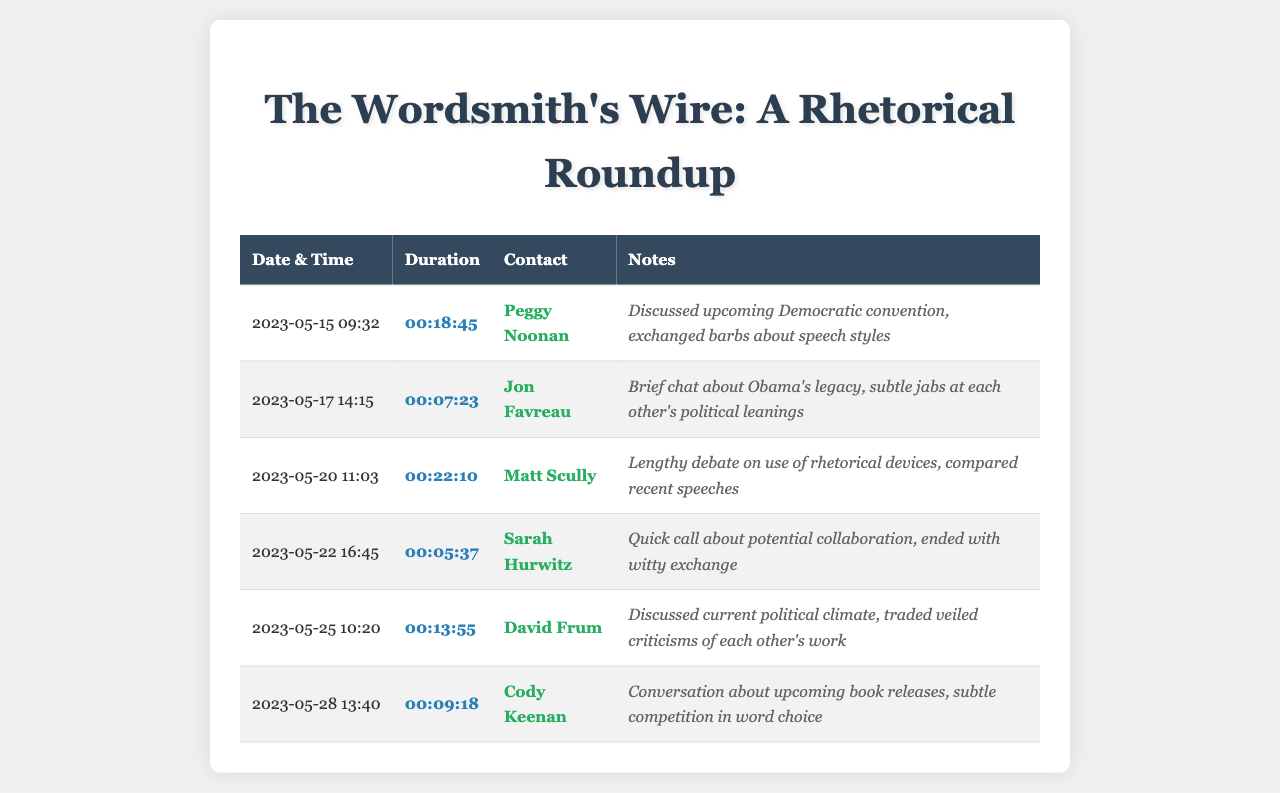what is the date of the longest call? The longest call is on May 20, 2023, with a duration of 22 minutes and 10 seconds.
Answer: May 20, 2023 who was the contact for the briefest call? The briefest call lasted 5 minutes and 37 seconds with Sarah Hurwitz.
Answer: Sarah Hurwitz how many calls were made in total? There are six calls listed in the document, each with a specific date and time.
Answer: 6 which speechwriter had a conversation about Obama's legacy? The conversation about Obama's legacy was with Jon Favreau.
Answer: Jon Favreau what was the duration of the call with Peggy Noonan? The call with Peggy Noonan lasted 18 minutes and 45 seconds.
Answer: 00:18:45 which call included a discussion about potential collaboration? The call discussing potential collaboration was with Sarah Hurwitz.
Answer: Sarah Hurwitz what is the average duration of the calls? To find the average, you can add up all the durations and divide by the number of calls, resulting in approximately 12 minutes and 7 seconds per call.
Answer: 12:07 what was the common theme in the conversations? The common themes included discussions of political contexts, rhetorical devices, and subtle competition among speechwriters.
Answer: Political contexts and competition when did the last call occur? The last call occurred on May 28, 2023.
Answer: May 28, 2023 